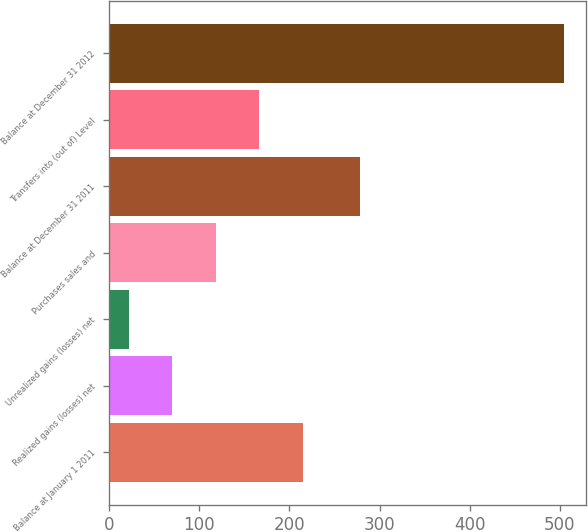<chart> <loc_0><loc_0><loc_500><loc_500><bar_chart><fcel>Balance at January 1 2011<fcel>Realized gains (losses) net<fcel>Unrealized gains (losses) net<fcel>Purchases sales and<fcel>Balance at December 31 2011<fcel>Transfers into (out of) Level<fcel>Balance at December 31 2012<nl><fcel>214.8<fcel>70.2<fcel>22<fcel>118.4<fcel>278<fcel>166.6<fcel>504<nl></chart> 